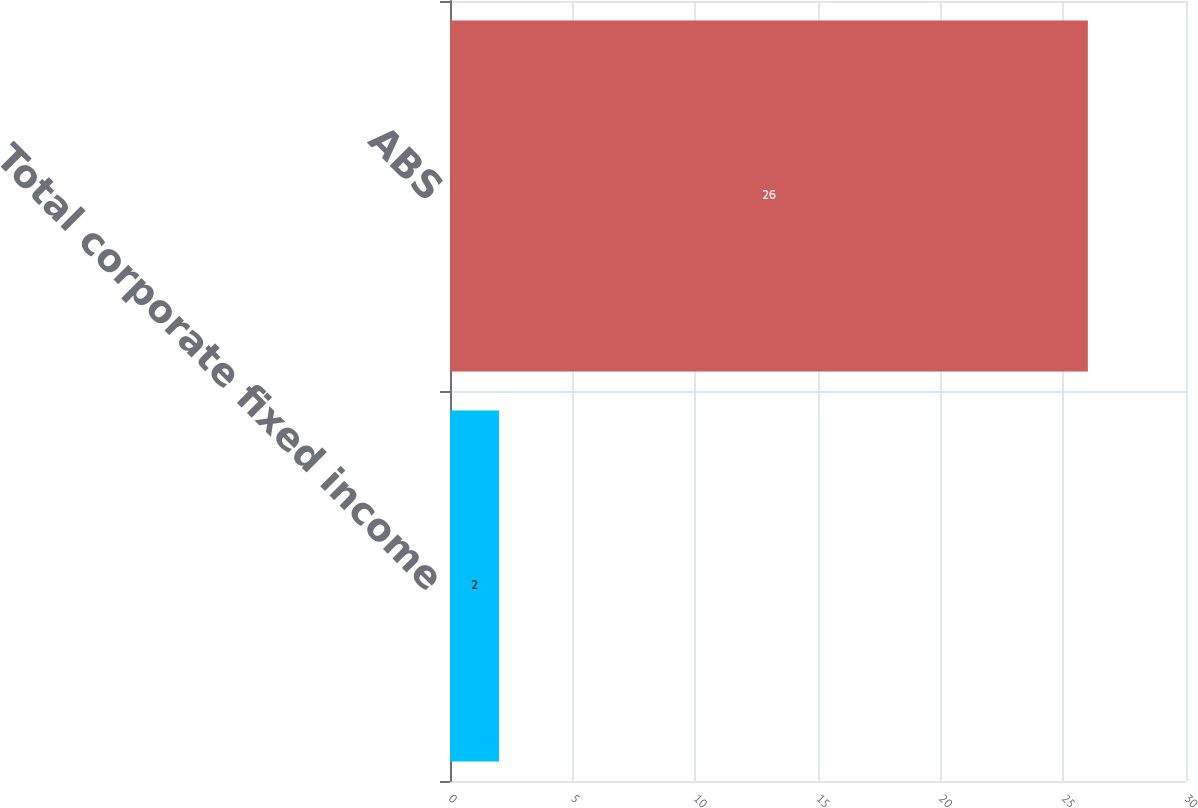Convert chart. <chart><loc_0><loc_0><loc_500><loc_500><bar_chart><fcel>Total corporate fixed income<fcel>ABS<nl><fcel>2<fcel>26<nl></chart> 